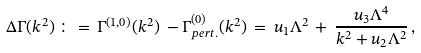Convert formula to latex. <formula><loc_0><loc_0><loc_500><loc_500>\Delta \Gamma ( k ^ { 2 } ) \, \colon = \, \Gamma ^ { ( 1 , 0 ) } ( k ^ { 2 } ) \, - \Gamma ^ { ( 0 ) } _ { p e r t . } ( k ^ { 2 } ) \, = \, u _ { 1 } \Lambda ^ { 2 } \, + \, \frac { u _ { 3 } \Lambda ^ { 4 } } { k ^ { 2 } + u _ { 2 } \Lambda ^ { 2 } } \, ,</formula> 